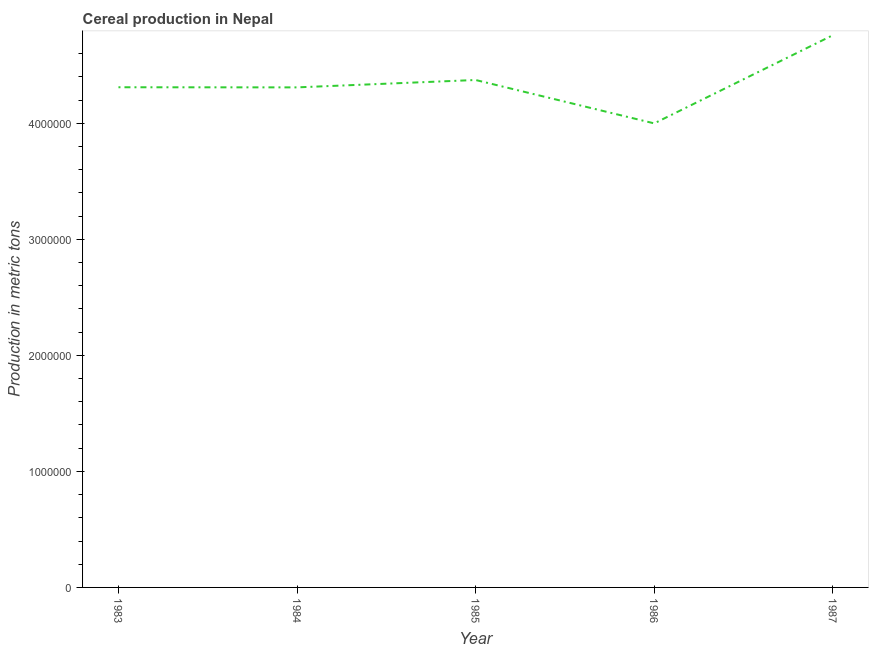What is the cereal production in 1985?
Keep it short and to the point. 4.37e+06. Across all years, what is the maximum cereal production?
Offer a very short reply. 4.76e+06. Across all years, what is the minimum cereal production?
Your response must be concise. 4.00e+06. In which year was the cereal production maximum?
Provide a short and direct response. 1987. What is the sum of the cereal production?
Provide a succinct answer. 2.18e+07. What is the difference between the cereal production in 1983 and 1984?
Your response must be concise. 1110. What is the average cereal production per year?
Give a very brief answer. 4.35e+06. What is the median cereal production?
Your answer should be compact. 4.31e+06. In how many years, is the cereal production greater than 3200000 metric tons?
Your answer should be compact. 5. Do a majority of the years between 1985 and 1984 (inclusive) have cereal production greater than 2400000 metric tons?
Keep it short and to the point. No. What is the ratio of the cereal production in 1986 to that in 1987?
Offer a very short reply. 0.84. Is the cereal production in 1985 less than that in 1987?
Offer a terse response. Yes. What is the difference between the highest and the second highest cereal production?
Offer a very short reply. 3.86e+05. What is the difference between the highest and the lowest cereal production?
Provide a short and direct response. 7.60e+05. What is the difference between two consecutive major ticks on the Y-axis?
Make the answer very short. 1.00e+06. Are the values on the major ticks of Y-axis written in scientific E-notation?
Your response must be concise. No. What is the title of the graph?
Provide a succinct answer. Cereal production in Nepal. What is the label or title of the Y-axis?
Keep it short and to the point. Production in metric tons. What is the Production in metric tons of 1983?
Keep it short and to the point. 4.31e+06. What is the Production in metric tons in 1984?
Ensure brevity in your answer.  4.31e+06. What is the Production in metric tons in 1985?
Give a very brief answer. 4.37e+06. What is the Production in metric tons of 1986?
Keep it short and to the point. 4.00e+06. What is the Production in metric tons of 1987?
Your answer should be very brief. 4.76e+06. What is the difference between the Production in metric tons in 1983 and 1984?
Provide a short and direct response. 1110. What is the difference between the Production in metric tons in 1983 and 1985?
Your answer should be very brief. -6.26e+04. What is the difference between the Production in metric tons in 1983 and 1986?
Your answer should be very brief. 3.11e+05. What is the difference between the Production in metric tons in 1983 and 1987?
Keep it short and to the point. -4.48e+05. What is the difference between the Production in metric tons in 1984 and 1985?
Offer a very short reply. -6.37e+04. What is the difference between the Production in metric tons in 1984 and 1986?
Ensure brevity in your answer.  3.10e+05. What is the difference between the Production in metric tons in 1984 and 1987?
Offer a terse response. -4.49e+05. What is the difference between the Production in metric tons in 1985 and 1986?
Provide a short and direct response. 3.74e+05. What is the difference between the Production in metric tons in 1985 and 1987?
Make the answer very short. -3.86e+05. What is the difference between the Production in metric tons in 1986 and 1987?
Your answer should be very brief. -7.60e+05. What is the ratio of the Production in metric tons in 1983 to that in 1984?
Give a very brief answer. 1. What is the ratio of the Production in metric tons in 1983 to that in 1986?
Make the answer very short. 1.08. What is the ratio of the Production in metric tons in 1983 to that in 1987?
Offer a terse response. 0.91. What is the ratio of the Production in metric tons in 1984 to that in 1985?
Give a very brief answer. 0.98. What is the ratio of the Production in metric tons in 1984 to that in 1986?
Offer a very short reply. 1.08. What is the ratio of the Production in metric tons in 1984 to that in 1987?
Offer a terse response. 0.91. What is the ratio of the Production in metric tons in 1985 to that in 1986?
Your answer should be very brief. 1.09. What is the ratio of the Production in metric tons in 1985 to that in 1987?
Your response must be concise. 0.92. What is the ratio of the Production in metric tons in 1986 to that in 1987?
Ensure brevity in your answer.  0.84. 